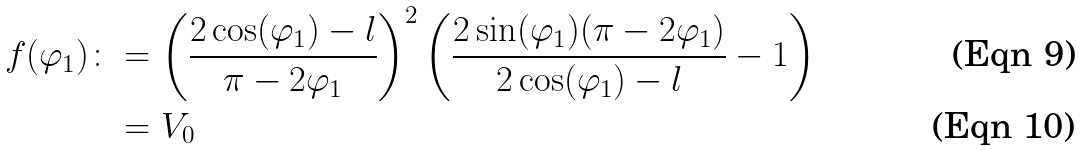Convert formula to latex. <formula><loc_0><loc_0><loc_500><loc_500>f ( \varphi _ { 1 } ) \colon & = \left ( \frac { 2 \cos ( \varphi _ { 1 } ) - l } { \pi - 2 \varphi _ { 1 } } \right ) ^ { 2 } \left ( \frac { 2 \sin ( \varphi _ { 1 } ) ( \pi - 2 \varphi _ { 1 } ) } { 2 \cos ( \varphi _ { 1 } ) - l } - 1 \right ) \\ & = V _ { 0 }</formula> 